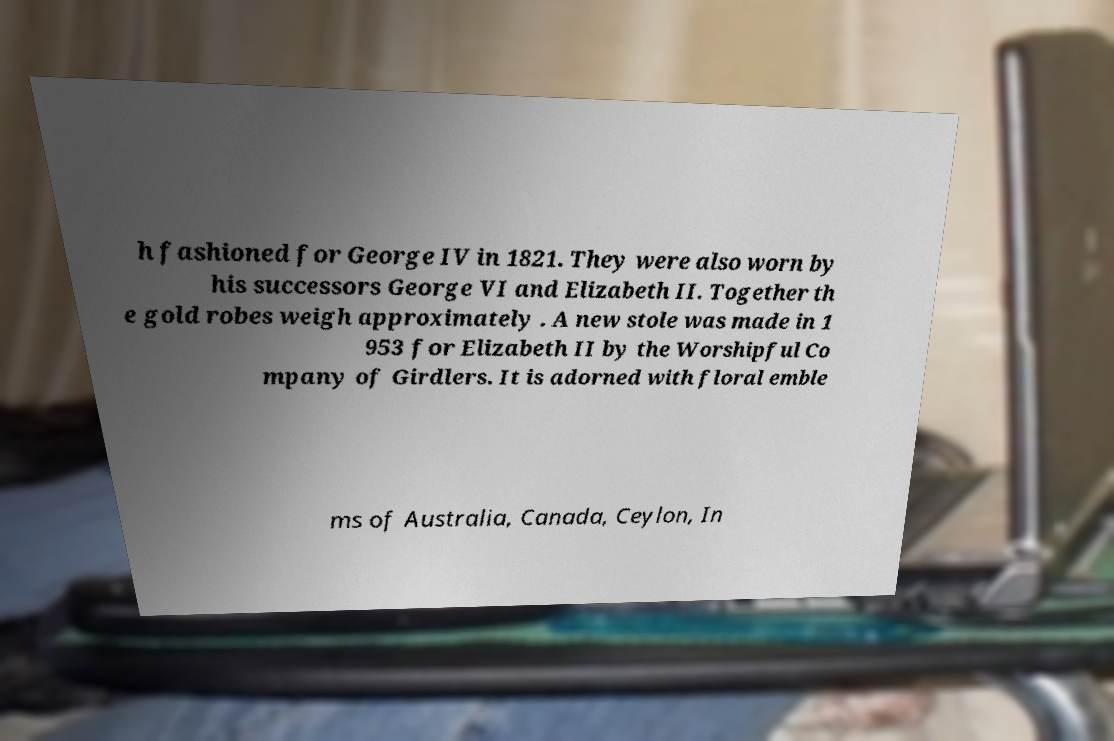Could you assist in decoding the text presented in this image and type it out clearly? h fashioned for George IV in 1821. They were also worn by his successors George VI and Elizabeth II. Together th e gold robes weigh approximately . A new stole was made in 1 953 for Elizabeth II by the Worshipful Co mpany of Girdlers. It is adorned with floral emble ms of Australia, Canada, Ceylon, In 